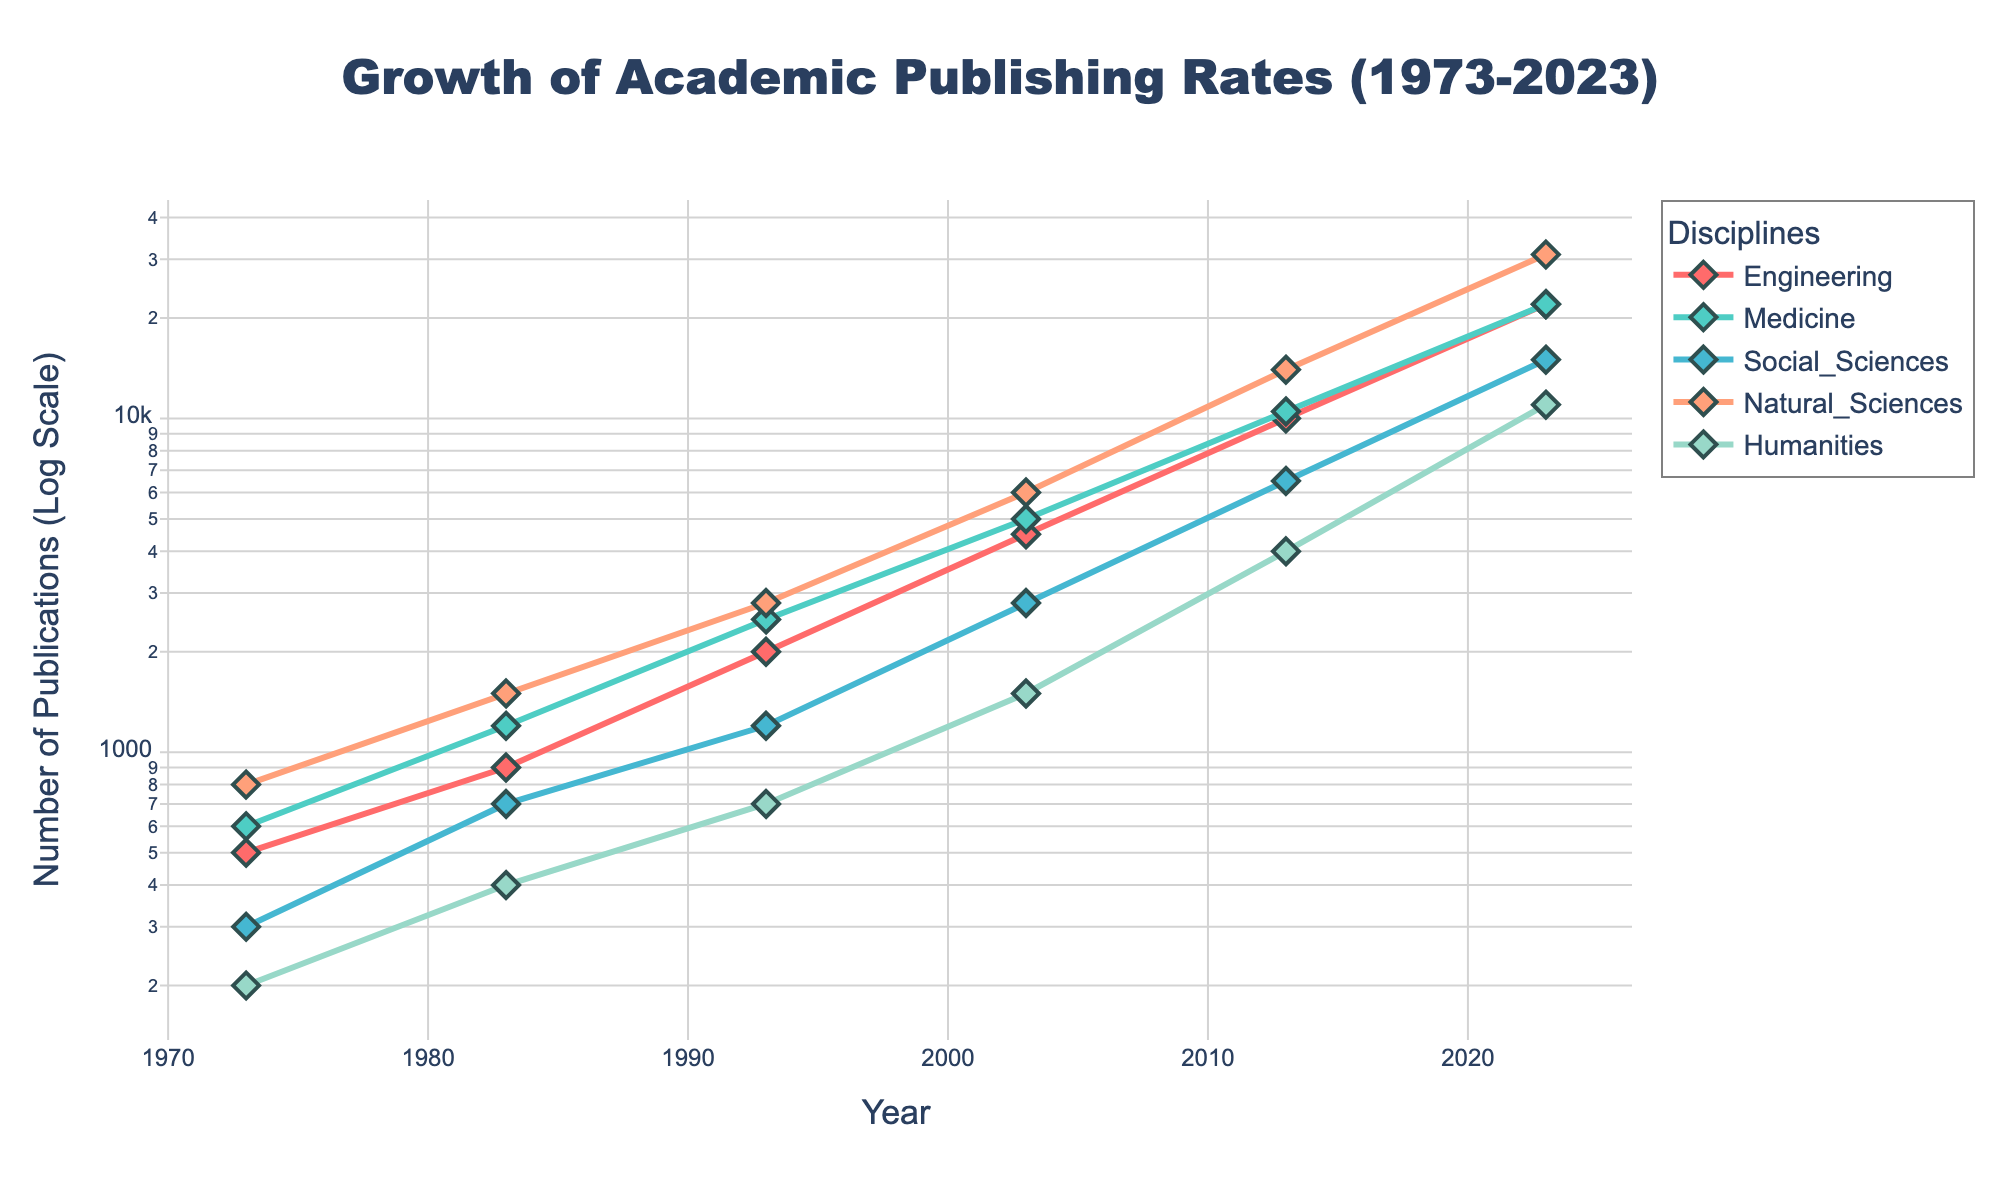How many disciplines are shown in the figure? There are five unique traces in the figure corresponding to five different disciplines, identified by their colors and names in the legend.
Answer: 5 What is the title of the figure? The title is prominently displayed at the top center of the figure.
Answer: Growth of Academic Publishing Rates (1973-2023) Which discipline has the fewest publications in 2023? By examining the end of the lines at the year 2023, the line representing 'Humanities' is the lowest among all disciplines.
Answer: Humanities In which year did the 'Engineering' discipline first reach 1000 publications? Following the 'Engineering' line and its markers, it first surpasses 1000 publications between 1983 and 1993. Precisely, in the year 1993.
Answer: 1993 How does the number of publications in Medicine in 2003 compare to that in Humanities in 2023? Compare the y-values for 'Medicine' in 2003 and 'Humanities' in 2023 on the log scale axis. Medicine in 2003 has 5000 publications, whereas Humanities in 2023 has 11000 publications. 11000 > 5000.
Answer: It is smaller Which discipline experienced the highest growth rate between 1993 and 2003? By calculating the difference in publications between these years for each discipline, 'Natural Sciences' shows the highest increase (from 2800 to 6000).
Answer: Natural Sciences What is the general trend of publications across all disciplines over time? Observing the overall direction of all lines from 1973 to 2023 shows an upward trend.
Answer: Increasing Are there any disciplines with the same number of publications in 2023? Checking the y-values at 2023 for all the lines, both 'Engineering' and 'Medicine' display 22000 publications.
Answer: Yes Between 1993 and 2023, which discipline had the lowest initial publications but achieved considerable growth? Initial publications are lowest for 'Humanities' in 1993 (700), but it grew to 11000 by 2023.
Answer: Humanities Which pairs of disciplines have publication rates closest to each other in 1983? Comparing the y-values for each discipline in 1983, 'Medicine' (1200) and 'Natural Sciences' (1500) are close.
Answer: Medicine and Natural Sciences 